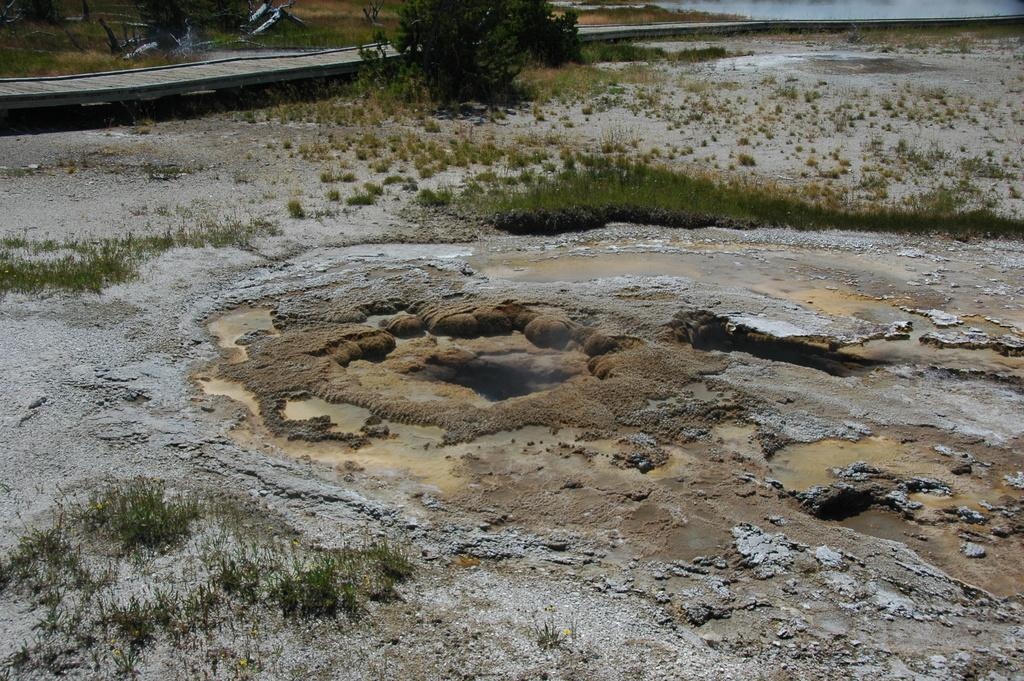What type of ground surface is visible in the image? There is grass on the ground in the image. What else can be seen on the ground in the image? There is mud visible in the image. What type of vegetation is present in the image? There are trees in the image. What natural element is visible in the image? There is water visible in the image. What type of cork can be seen floating in the water in the image? There is no cork present in the image; it only features grass, mud, trees, and water. 